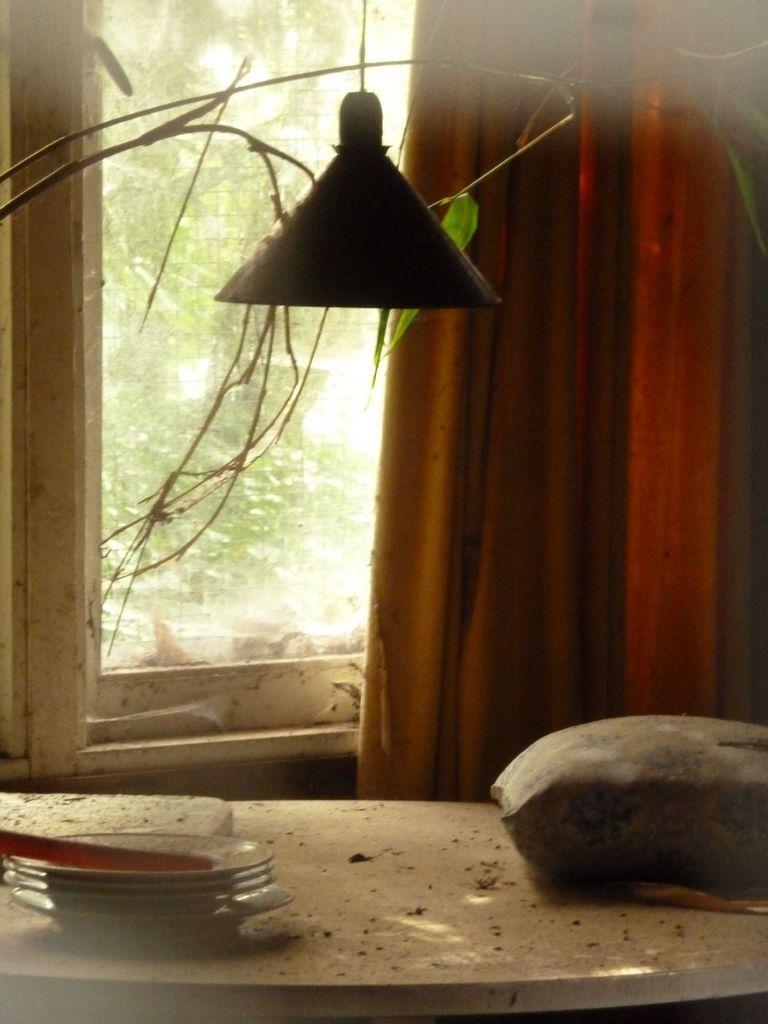Can you describe this image briefly? In the picture we can see light, somethings on table and in the background there is curtain, window through which we can see some trees. 